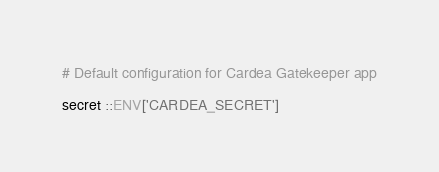Convert code to text. <code><loc_0><loc_0><loc_500><loc_500><_Ruby_># Default configuration for Cardea Gatekeeper app

secret ::ENV['CARDEA_SECRET']
</code> 